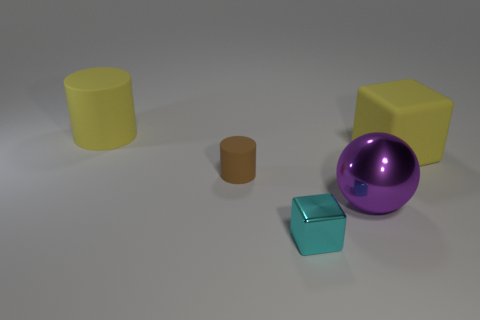Add 1 tiny purple cylinders. How many objects exist? 6 Subtract all blocks. How many objects are left? 3 Add 5 tiny shiny cubes. How many tiny shiny cubes are left? 6 Add 1 big purple objects. How many big purple objects exist? 2 Subtract 0 yellow spheres. How many objects are left? 5 Subtract all small objects. Subtract all small brown rubber things. How many objects are left? 2 